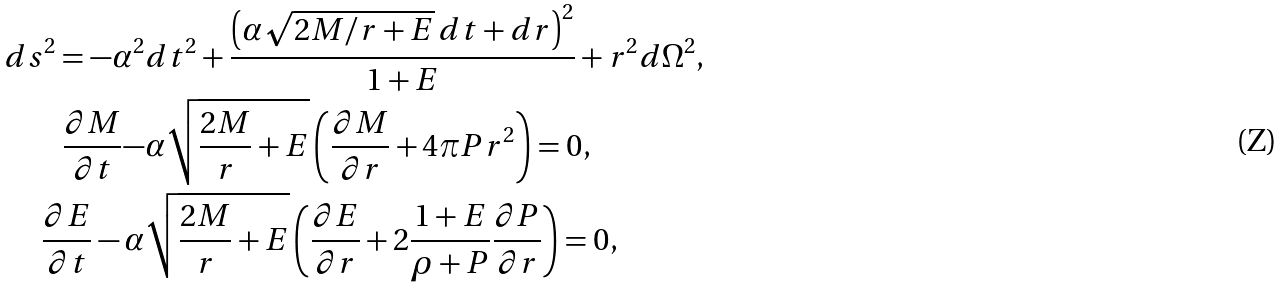Convert formula to latex. <formula><loc_0><loc_0><loc_500><loc_500>d s ^ { 2 } = - \alpha ^ { 2 } & d t ^ { 2 } + \frac { \left ( \alpha \sqrt { 2 M / r + E } \, d t + d r \right ) ^ { 2 } } { 1 + E } + r ^ { 2 } d \Omega ^ { 2 } , \\ \frac { \partial M } { \partial t } - & \alpha \sqrt { \frac { 2 M } { r } + E } \left ( \frac { \partial M } { \partial r } + 4 \pi P r ^ { 2 } \right ) = 0 , \\ \frac { \partial E } { \partial t } - \alpha & \sqrt { \frac { 2 M } { r } + E } \left ( \frac { \partial E } { \partial r } + 2 \frac { 1 + E } { \rho + P } \frac { \partial P } { \partial r } \right ) = 0 ,</formula> 